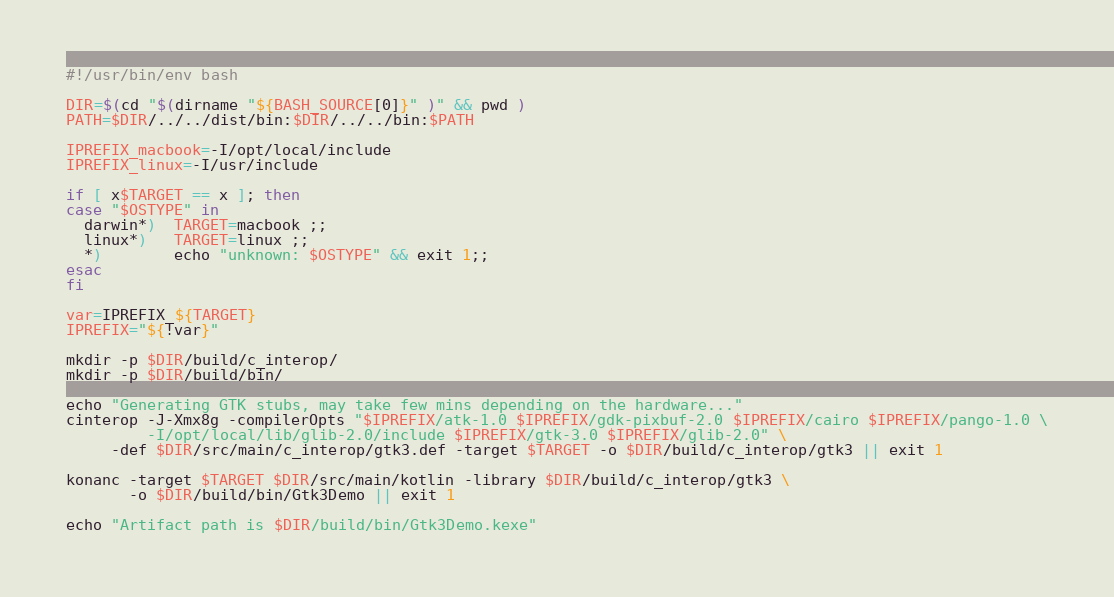<code> <loc_0><loc_0><loc_500><loc_500><_Bash_>#!/usr/bin/env bash

DIR=$(cd "$(dirname "${BASH_SOURCE[0]}" )" && pwd )
PATH=$DIR/../../dist/bin:$DIR/../../bin:$PATH

IPREFIX_macbook=-I/opt/local/include
IPREFIX_linux=-I/usr/include

if [ x$TARGET == x ]; then
case "$OSTYPE" in
  darwin*)  TARGET=macbook ;;
  linux*)   TARGET=linux ;;
  *)        echo "unknown: $OSTYPE" && exit 1;;
esac
fi

var=IPREFIX_${TARGET}
IPREFIX="${!var}"

mkdir -p $DIR/build/c_interop/
mkdir -p $DIR/build/bin/

echo "Generating GTK stubs, may take few mins depending on the hardware..."
cinterop -J-Xmx8g -compilerOpts "$IPREFIX/atk-1.0 $IPREFIX/gdk-pixbuf-2.0 $IPREFIX/cairo $IPREFIX/pango-1.0 \
         -I/opt/local/lib/glib-2.0/include $IPREFIX/gtk-3.0 $IPREFIX/glib-2.0" \
	 -def $DIR/src/main/c_interop/gtk3.def -target $TARGET -o $DIR/build/c_interop/gtk3 || exit 1

konanc -target $TARGET $DIR/src/main/kotlin -library $DIR/build/c_interop/gtk3 \
       -o $DIR/build/bin/Gtk3Demo || exit 1

echo "Artifact path is $DIR/build/bin/Gtk3Demo.kexe"
</code> 